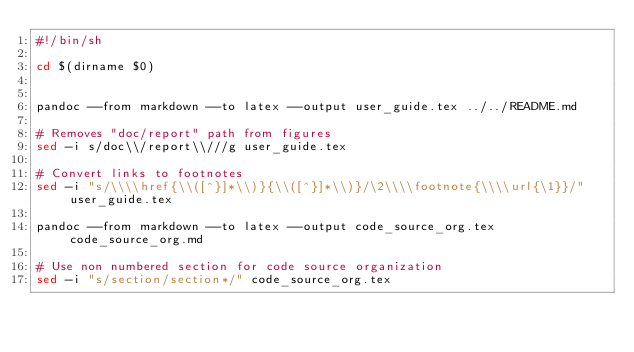Convert code to text. <code><loc_0><loc_0><loc_500><loc_500><_Bash_>#!/bin/sh

cd $(dirname $0)


pandoc --from markdown --to latex --output user_guide.tex ../../README.md

# Removes "doc/report" path from figures
sed -i s/doc\\/report\\///g user_guide.tex

# Convert links to footnotes
sed -i "s/\\\\href{\\([^}]*\\)}{\\([^}]*\\)}/\2\\\\footnote{\\\\url{\1}}/" user_guide.tex

pandoc --from markdown --to latex --output code_source_org.tex code_source_org.md

# Use non numbered section for code source organization
sed -i "s/section/section*/" code_source_org.tex
</code> 